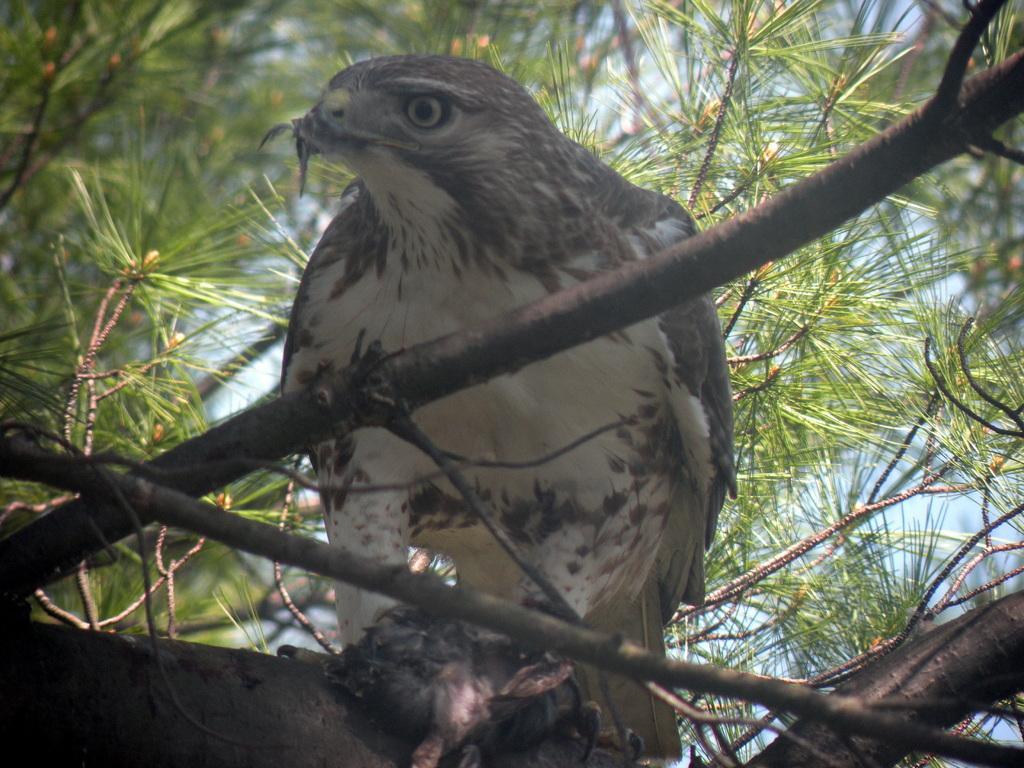Please provide a concise description of this image. In this image in the front there are stems of a tree and in the center there is a bird sitting on a tree. In the background there are leaves. 